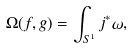Convert formula to latex. <formula><loc_0><loc_0><loc_500><loc_500>\Omega ( f , g ) = \int _ { S ^ { 1 } } j ^ { * } \omega ,</formula> 